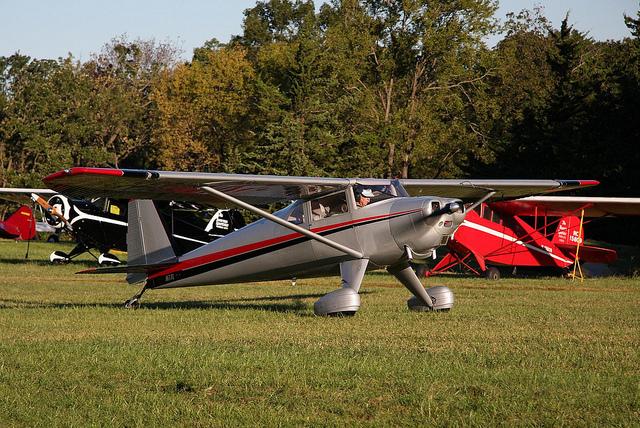How many planes have stripes?
Short answer required. 3. What is this?
Short answer required. Plane. What color is the plane on the right in the background?
Be succinct. Red. 